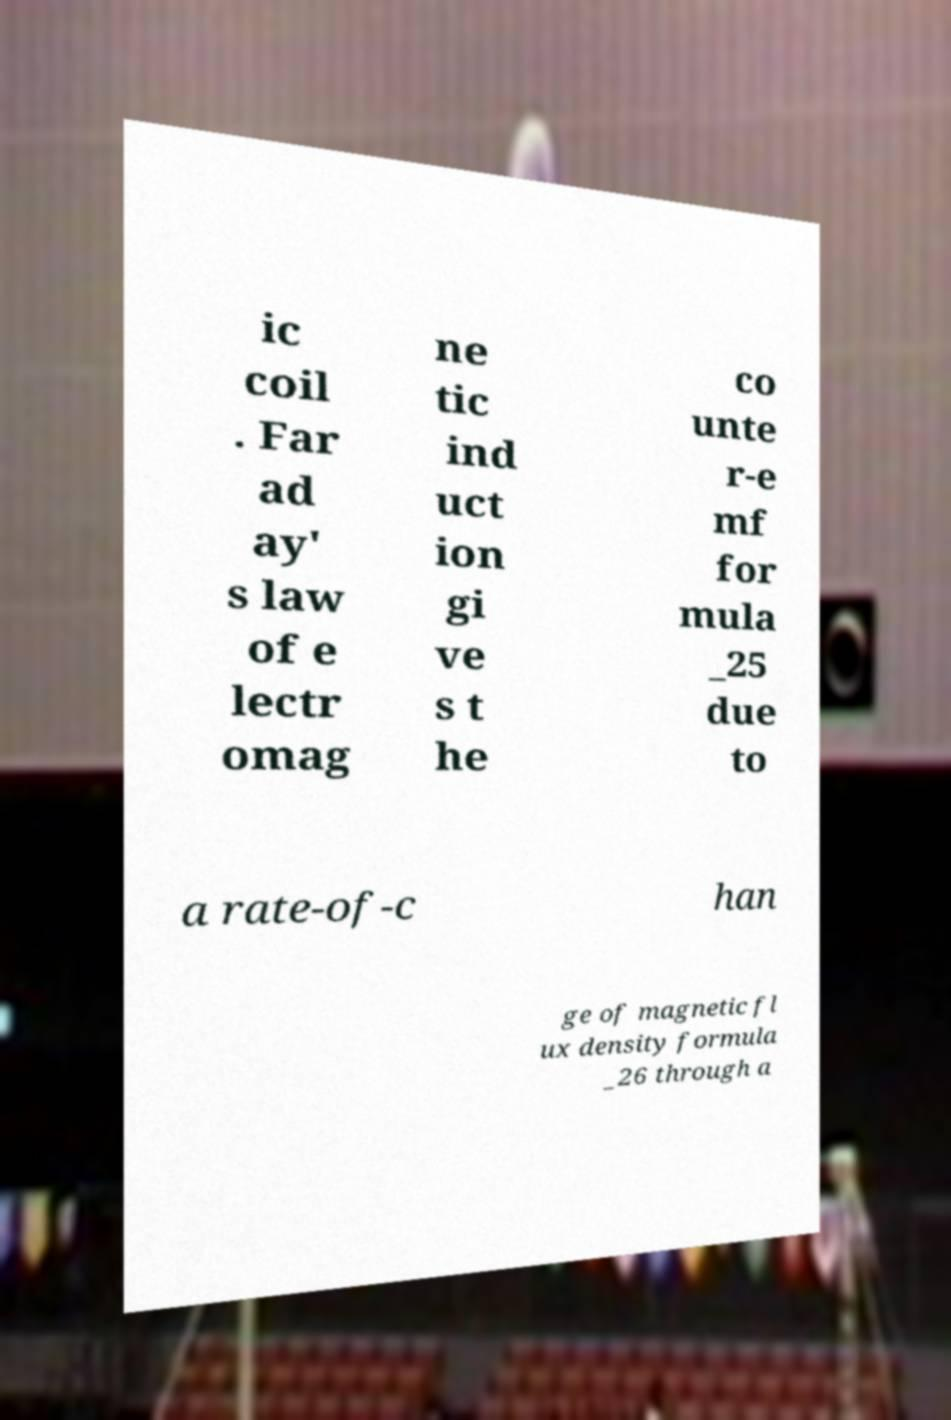Could you assist in decoding the text presented in this image and type it out clearly? ic coil . Far ad ay' s law of e lectr omag ne tic ind uct ion gi ve s t he co unte r-e mf for mula _25 due to a rate-of-c han ge of magnetic fl ux density formula _26 through a 